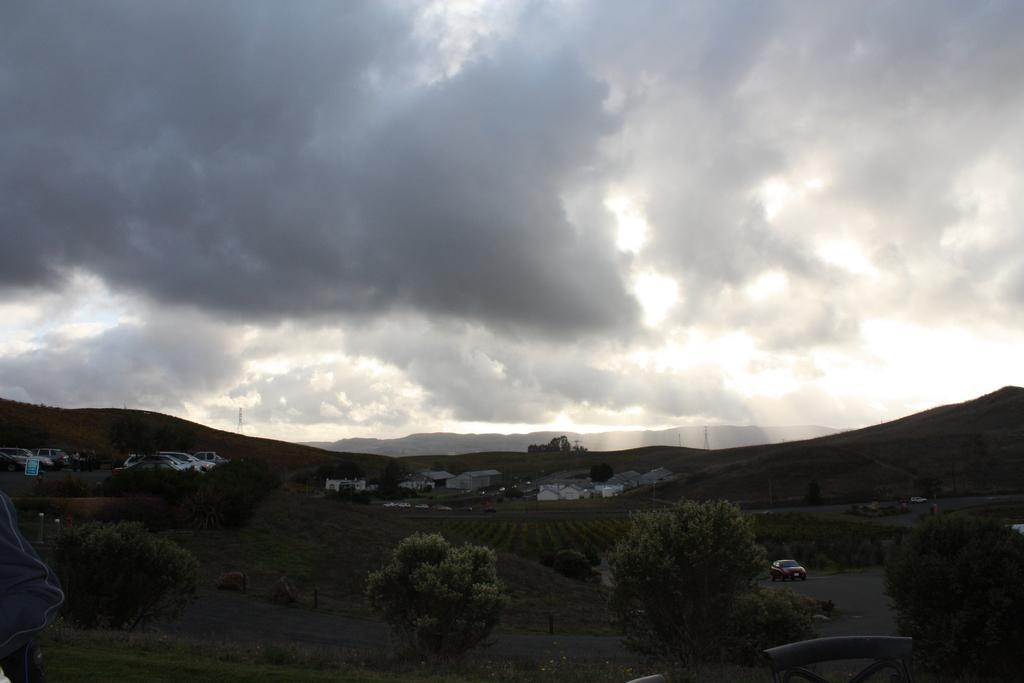What type of natural elements can be seen in the image? There are trees in the image. What type of man-made structures are visible in the image? There are buildings in the image. What type of vehicles can be seen in the image? There are cars in the image. What is visible in the sky in the image? The sky is visible in the image, and clouds are present. How would you describe the overall lighting in the image? The image appears to be slightly dark. Can you see a hammer being used in the image? There is no hammer present in the image. What color are the eyes of the person in the image? There is no person present in the image, so it is not possible to determine the color of their eyes. 